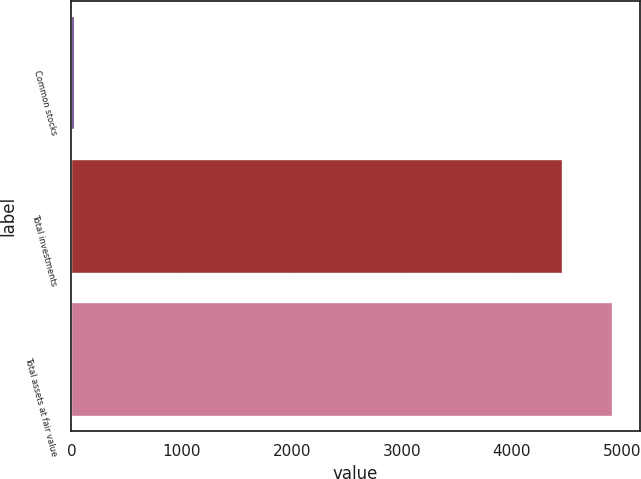Convert chart. <chart><loc_0><loc_0><loc_500><loc_500><bar_chart><fcel>Common stocks<fcel>Total investments<fcel>Total assets at fair value<nl><fcel>31<fcel>4468<fcel>4916.2<nl></chart> 